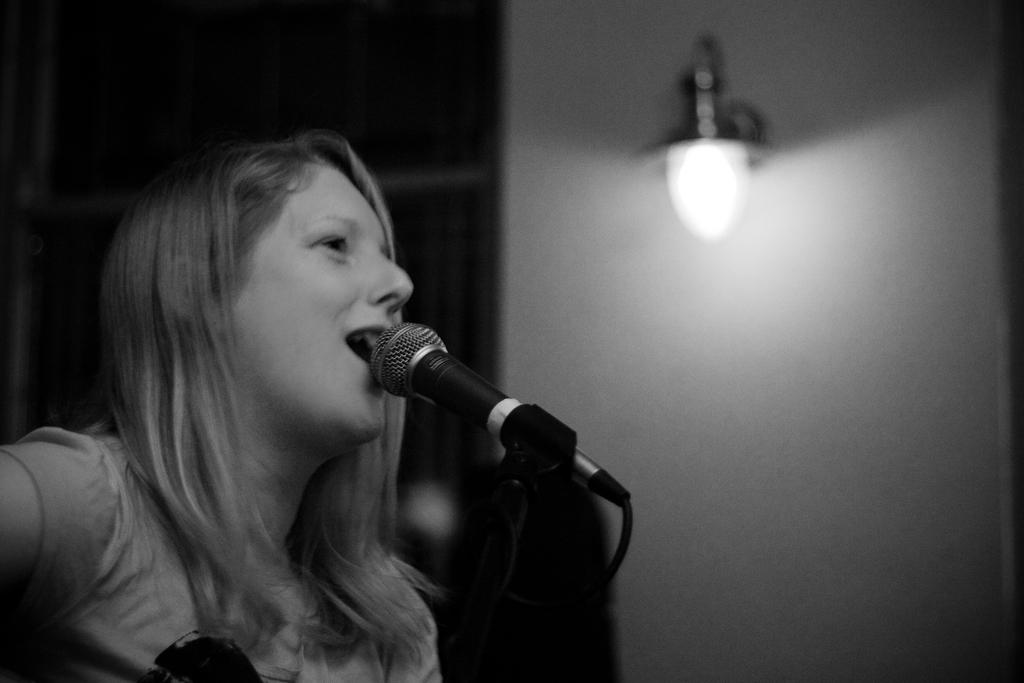Who is the main subject in the image? There is a woman in the image. What is the woman doing in the image? The woman is singing a song. What object is the woman using while singing? The woman is in front of a microphone. Can you describe any other objects in the image? There is a bulb on the wall on the right side of the image. What type of volleyball game is being played in the image? There is no volleyball game present in the image. Is there a birthday celebration happening in the image? There is no indication of a birthday celebration in the image. 